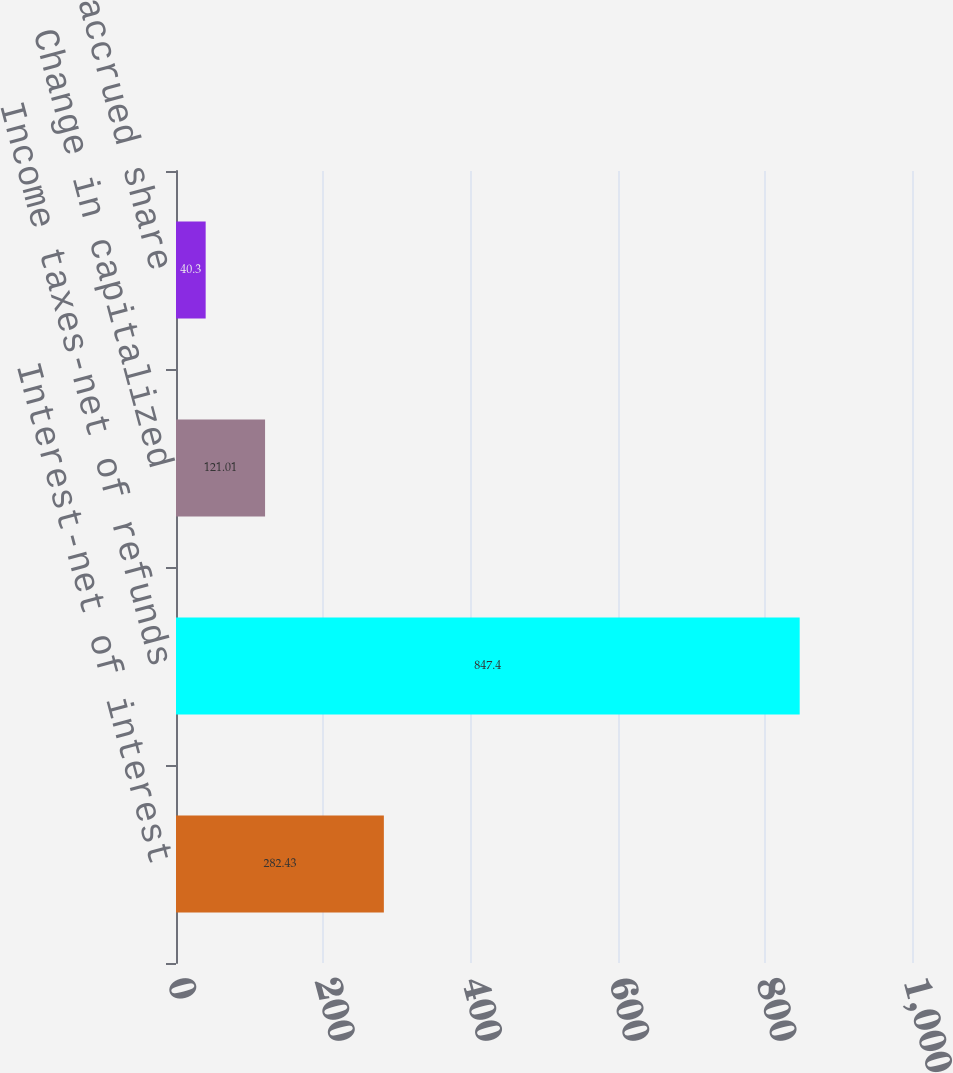Convert chart. <chart><loc_0><loc_0><loc_500><loc_500><bar_chart><fcel>Interest-net of interest<fcel>Income taxes-net of refunds<fcel>Change in capitalized<fcel>Change in accrued share<nl><fcel>282.43<fcel>847.4<fcel>121.01<fcel>40.3<nl></chart> 